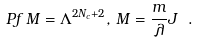Convert formula to latex. <formula><loc_0><loc_0><loc_500><loc_500>P f \, M = \Lambda ^ { 2 N _ { c } + 2 } , \, M = \frac { m } { \lambda } J \ .</formula> 